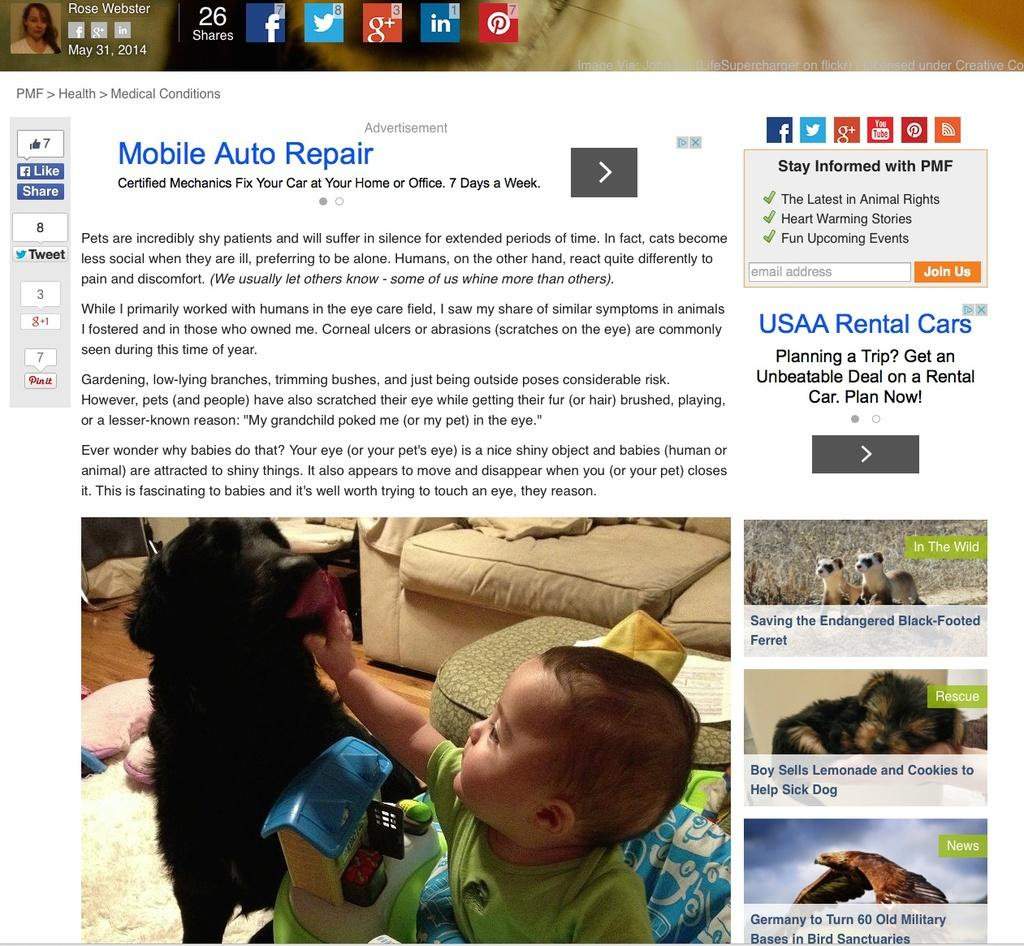What is the main subject of the web page? The main subject of the web page is a child. What other objects or characters can be seen on the web page? There is a toy, animals, a bird, and a woman on the web page. What type of furniture is present on the web page? There is a sofa on the floor on the web page. Are there any symbols or icons on the web page? Yes, there are symbols on the web page. Is there any text on the web page? Yes, there is some text on the web page. How many times does the child jump on the canvas in the image? There is no canvas or jumping depicted in the image; it features a child, a toy, animals, a bird, a woman, a sofa, symbols, and text on a web page. 